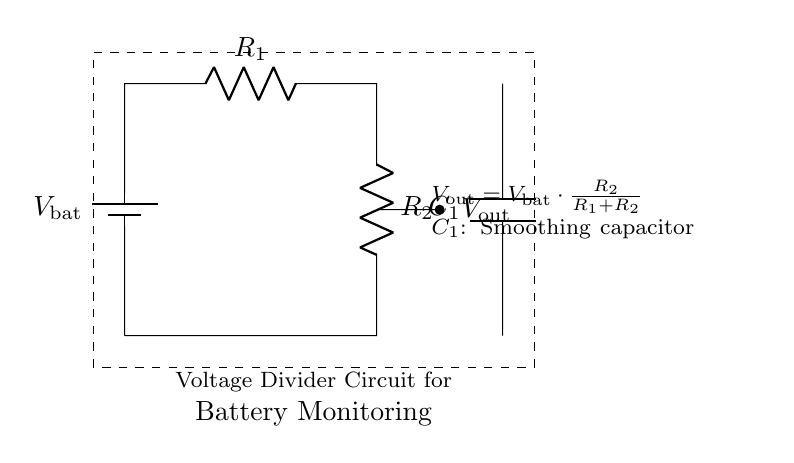What is the function of the smoothing capacitor in this circuit? The smoothing capacitor helps to stabilize the output voltage by reducing voltage ripples, making the output smoother. It does this by charging during the peaks of the output voltage and discharging during the dips.
Answer: Stabilizing voltage What components are used in this voltage divider circuit? The components are a battery, two resistors (R1 and R2), and a smoothing capacitor (C1). These components work together to divide the voltage from the battery to an appropriate level for monitoring.
Answer: Battery, R1, R2, C1 What is the output voltage formula defined in the circuit? The output voltage formula is given as V out equals V bat multiplied by the fraction of R2 over the sum of R1 and R2, which allows calculation of the output voltage based on the resistance values and battery voltage.
Answer: V out = V bat * (R2/(R1 + R2)) How many resistors are present in the circuit? There are two resistors labeled R1 and R2 in the circuit. They create the voltage divider effect by enabling a portion of the total voltage to be available at the output.
Answer: Two What happens to the output voltage (V out) if R2 is increased? Increasing R2 while keeping R1 constant results in a higher output voltage since the fraction of R2 in the voltage divider formula increases, allowing more voltage from the battery to be available at V out.
Answer: Increases What type of circuit is this? This is a voltage divider circuit with an additional smoothing capacitor used for battery monitoring, which showcases how voltage can be controlled in a practical application, specifically for portable safety devices.
Answer: Voltage divider circuit What does the dashed rectangle represent in the circuit? The dashed rectangle represents the boundary of the entire voltage divider circuit for battery monitoring, visually grouping the components and indicating that they are part of a single functional unit.
Answer: Circuit boundary 